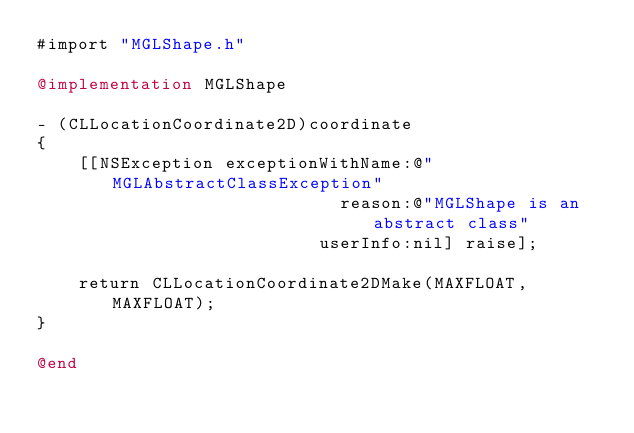Convert code to text. <code><loc_0><loc_0><loc_500><loc_500><_ObjectiveC_>#import "MGLShape.h"

@implementation MGLShape

- (CLLocationCoordinate2D)coordinate
{
    [[NSException exceptionWithName:@"MGLAbstractClassException"
                             reason:@"MGLShape is an abstract class"
                           userInfo:nil] raise];

    return CLLocationCoordinate2DMake(MAXFLOAT, MAXFLOAT);
}

@end
</code> 